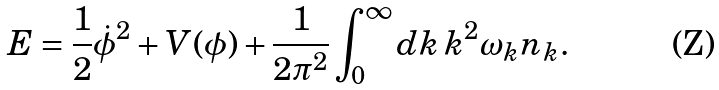Convert formula to latex. <formula><loc_0><loc_0><loc_500><loc_500>E = \frac { 1 } { 2 } \dot { \phi } ^ { 2 } + V ( \phi ) + \frac { 1 } { 2 \pi ^ { 2 } } \int _ { 0 } ^ { \infty } d k \, k ^ { 2 } \omega _ { k } n _ { k } .</formula> 